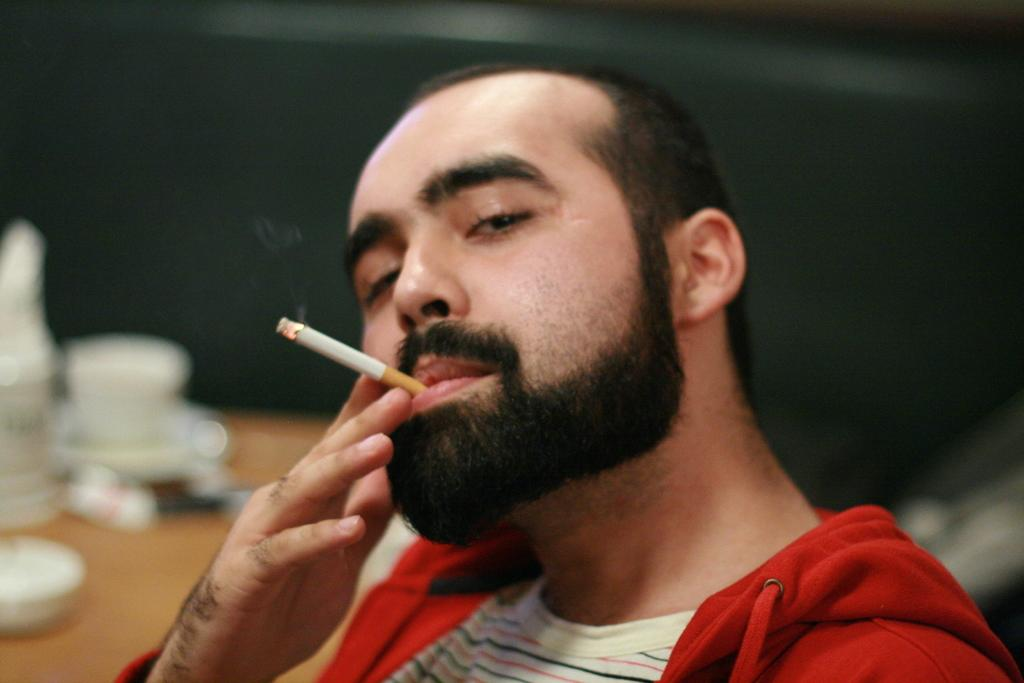Who is present in the image? There is a man in the image. What is the man holding in his mouth? The man has a cigarette in his mouth. Can you describe the background of the image? The background of the image is blurred. How many stamps are on the man's forehead in the image? There are no stamps visible on the man's forehead in the image. 